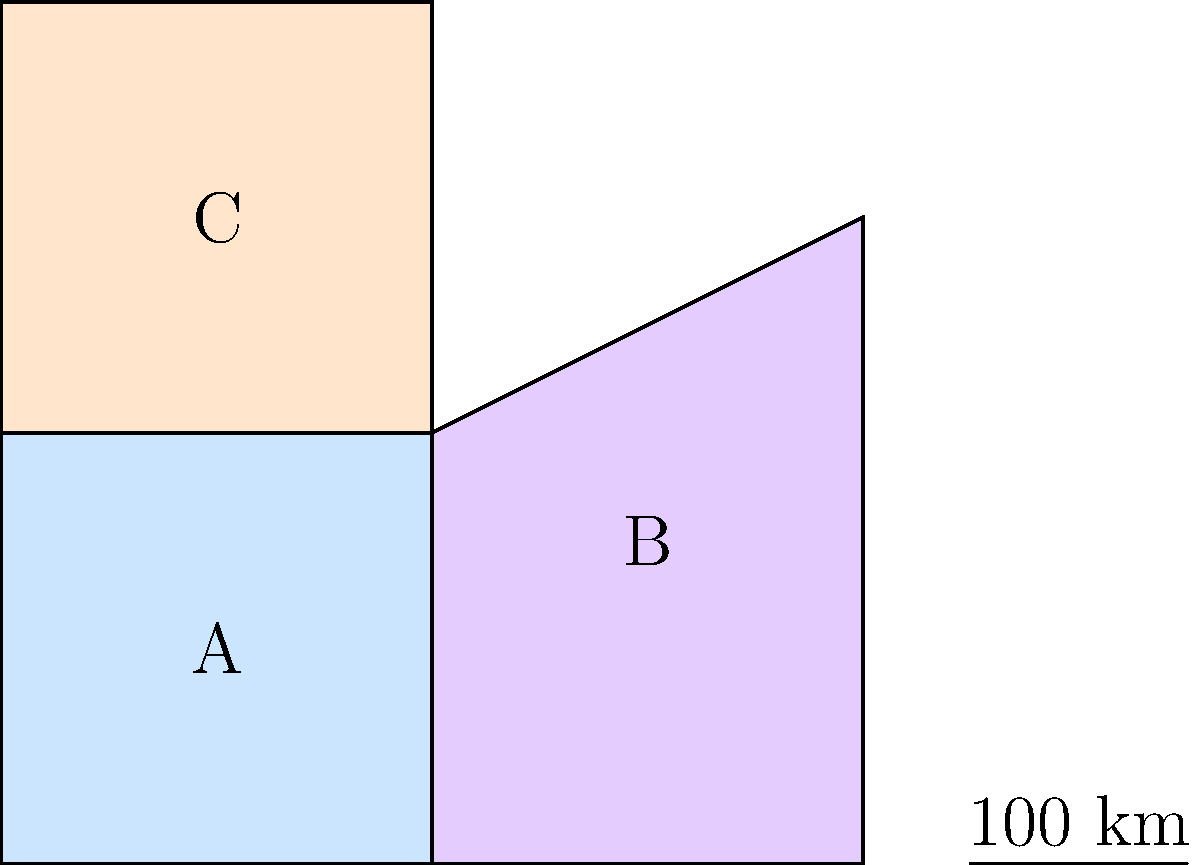As the Minister of Health, you are planning resource allocation for anti-FGM campaigns in three regions of the country. The map shows these regions: A, B, and C. Region A is a square with side length 200 km, Region B is a trapezoid, and Region C is a rectangle. The total area of regions B and C combined is 1.5 times the area of region A. If the height of region C is 200 km, what is the width of region C in kilometers? Let's approach this step-by-step:

1) First, let's calculate the area of Region A:
   Area of A = $200 \text{ km} \times 200 \text{ km} = 40,000 \text{ km}^2$

2) We're told that the total area of B and C is 1.5 times the area of A:
   Area of B + Area of C = $1.5 \times 40,000 \text{ km}^2 = 60,000 \text{ km}^2$

3) We can see that Region C is a rectangle with a height of 200 km. Let's call its width $x$ km.
   Area of C = $200x \text{ km}^2$

4) We can express the area of B in terms of $x$ as well. B is a trapezoid with bases 200 km and $x$ km, and a height of 300 km:
   Area of B = $\frac{1}{2}(200 + x) \times 300 \text{ km}^2 = (30,000 + 150x) \text{ km}^2$

5) Now we can set up an equation:
   Area of B + Area of C = $60,000 \text{ km}^2$
   $(30,000 + 150x) + 200x = 60,000$

6) Simplify:
   $30,000 + 350x = 60,000$

7) Solve for $x$:
   $350x = 30,000$
   $x = \frac{30,000}{350} = 85.71 \text{ km}$

8) Rounding to the nearest kilometer:
   $x \approx 86 \text{ km}$
Answer: 86 km 